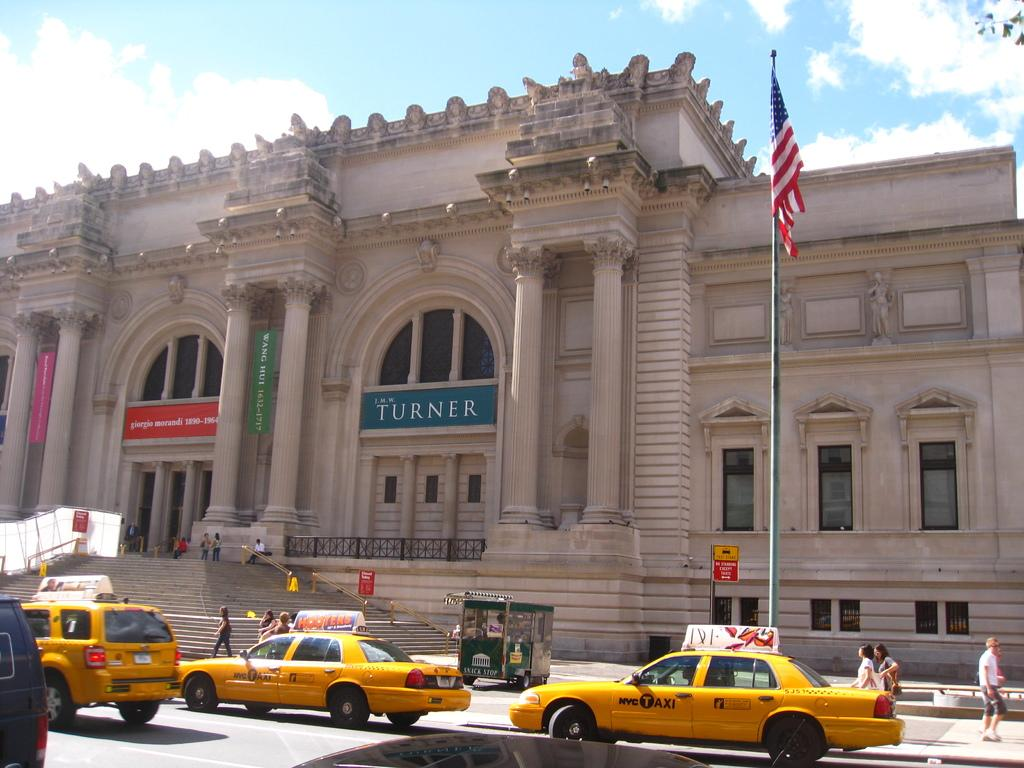<image>
Offer a succinct explanation of the picture presented. NYC taxis are on the street outside of an art museum. 